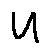<formula> <loc_0><loc_0><loc_500><loc_500>u</formula> 